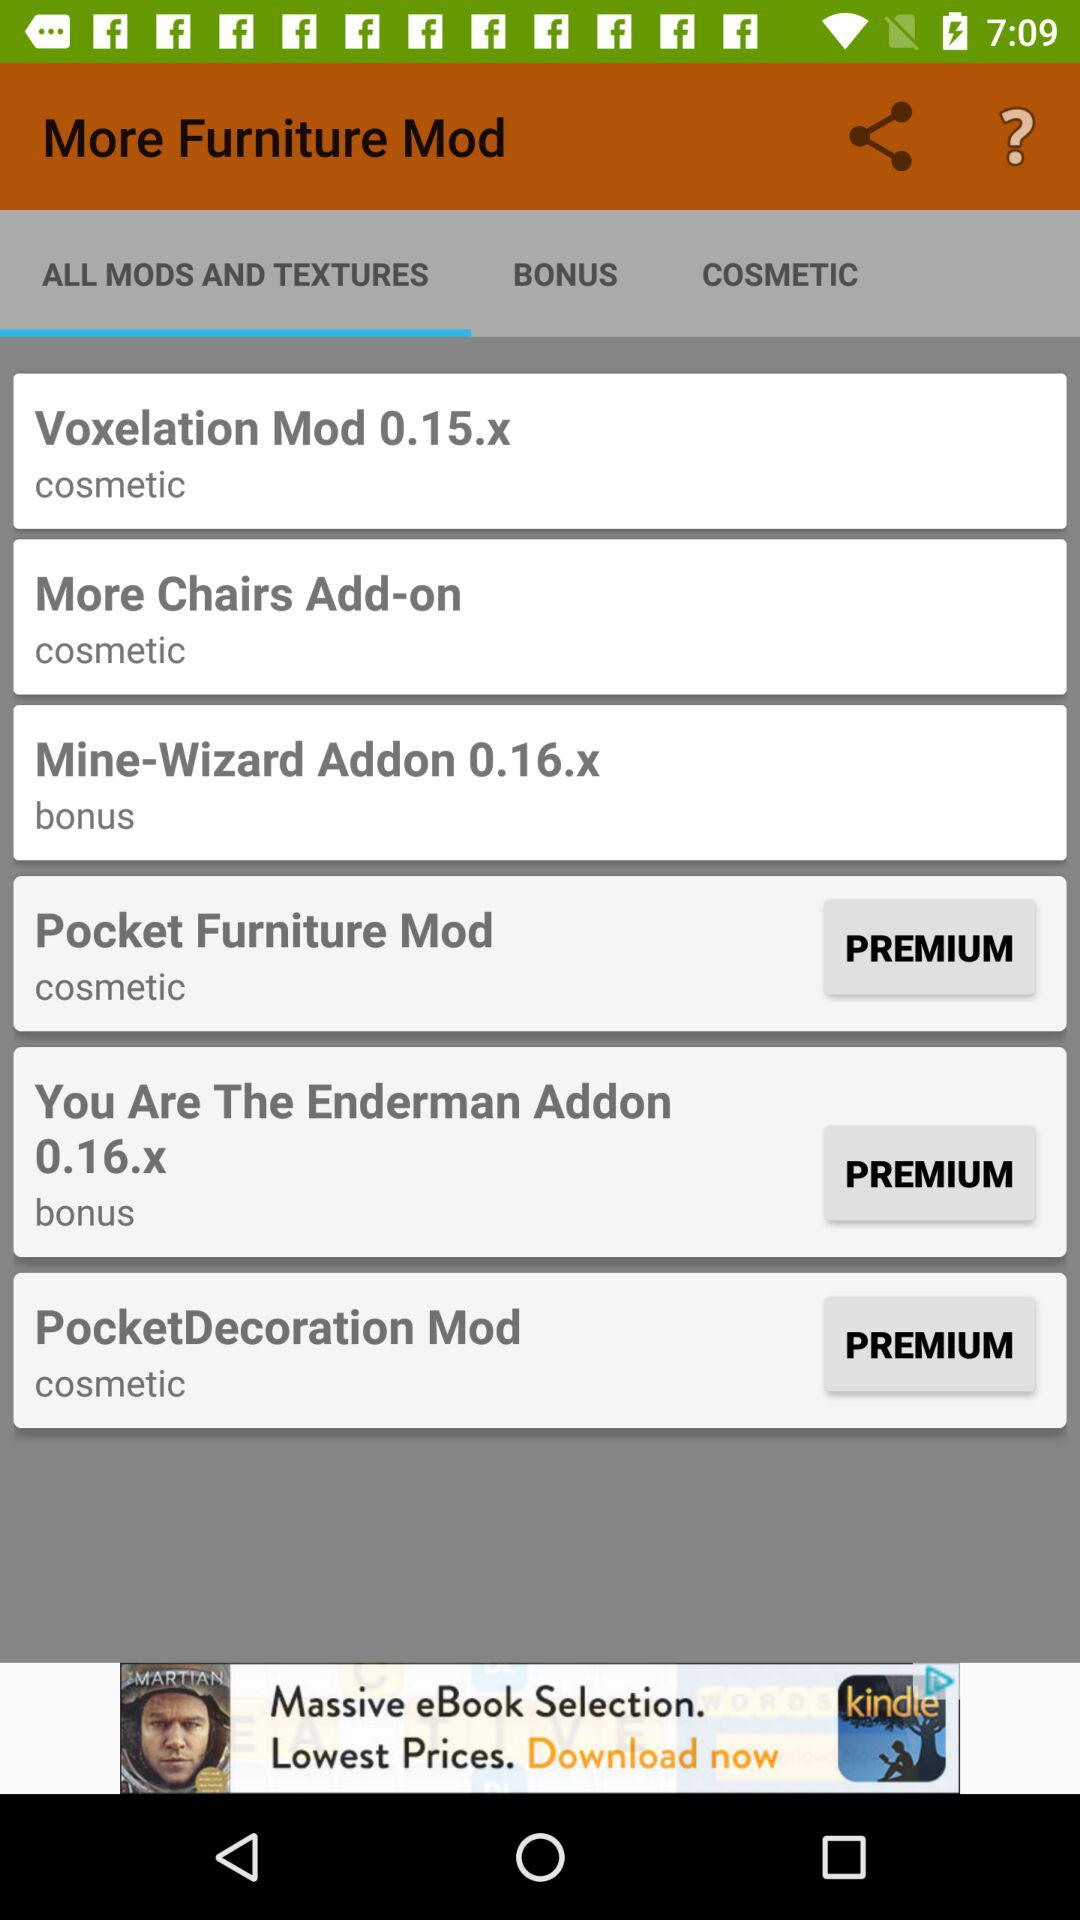How many items are in "BONUS"?
When the provided information is insufficient, respond with <no answer>. <no answer> 